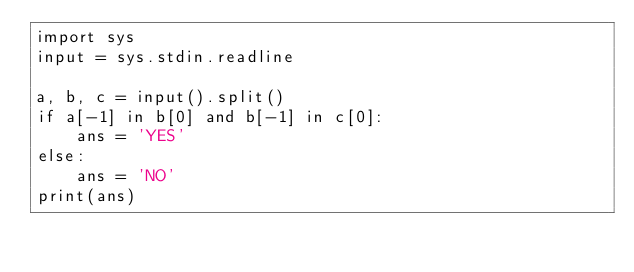<code> <loc_0><loc_0><loc_500><loc_500><_Python_>import sys
input = sys.stdin.readline

a, b, c = input().split()
if a[-1] in b[0] and b[-1] in c[0]:
    ans = 'YES'
else:
    ans = 'NO'
print(ans)</code> 